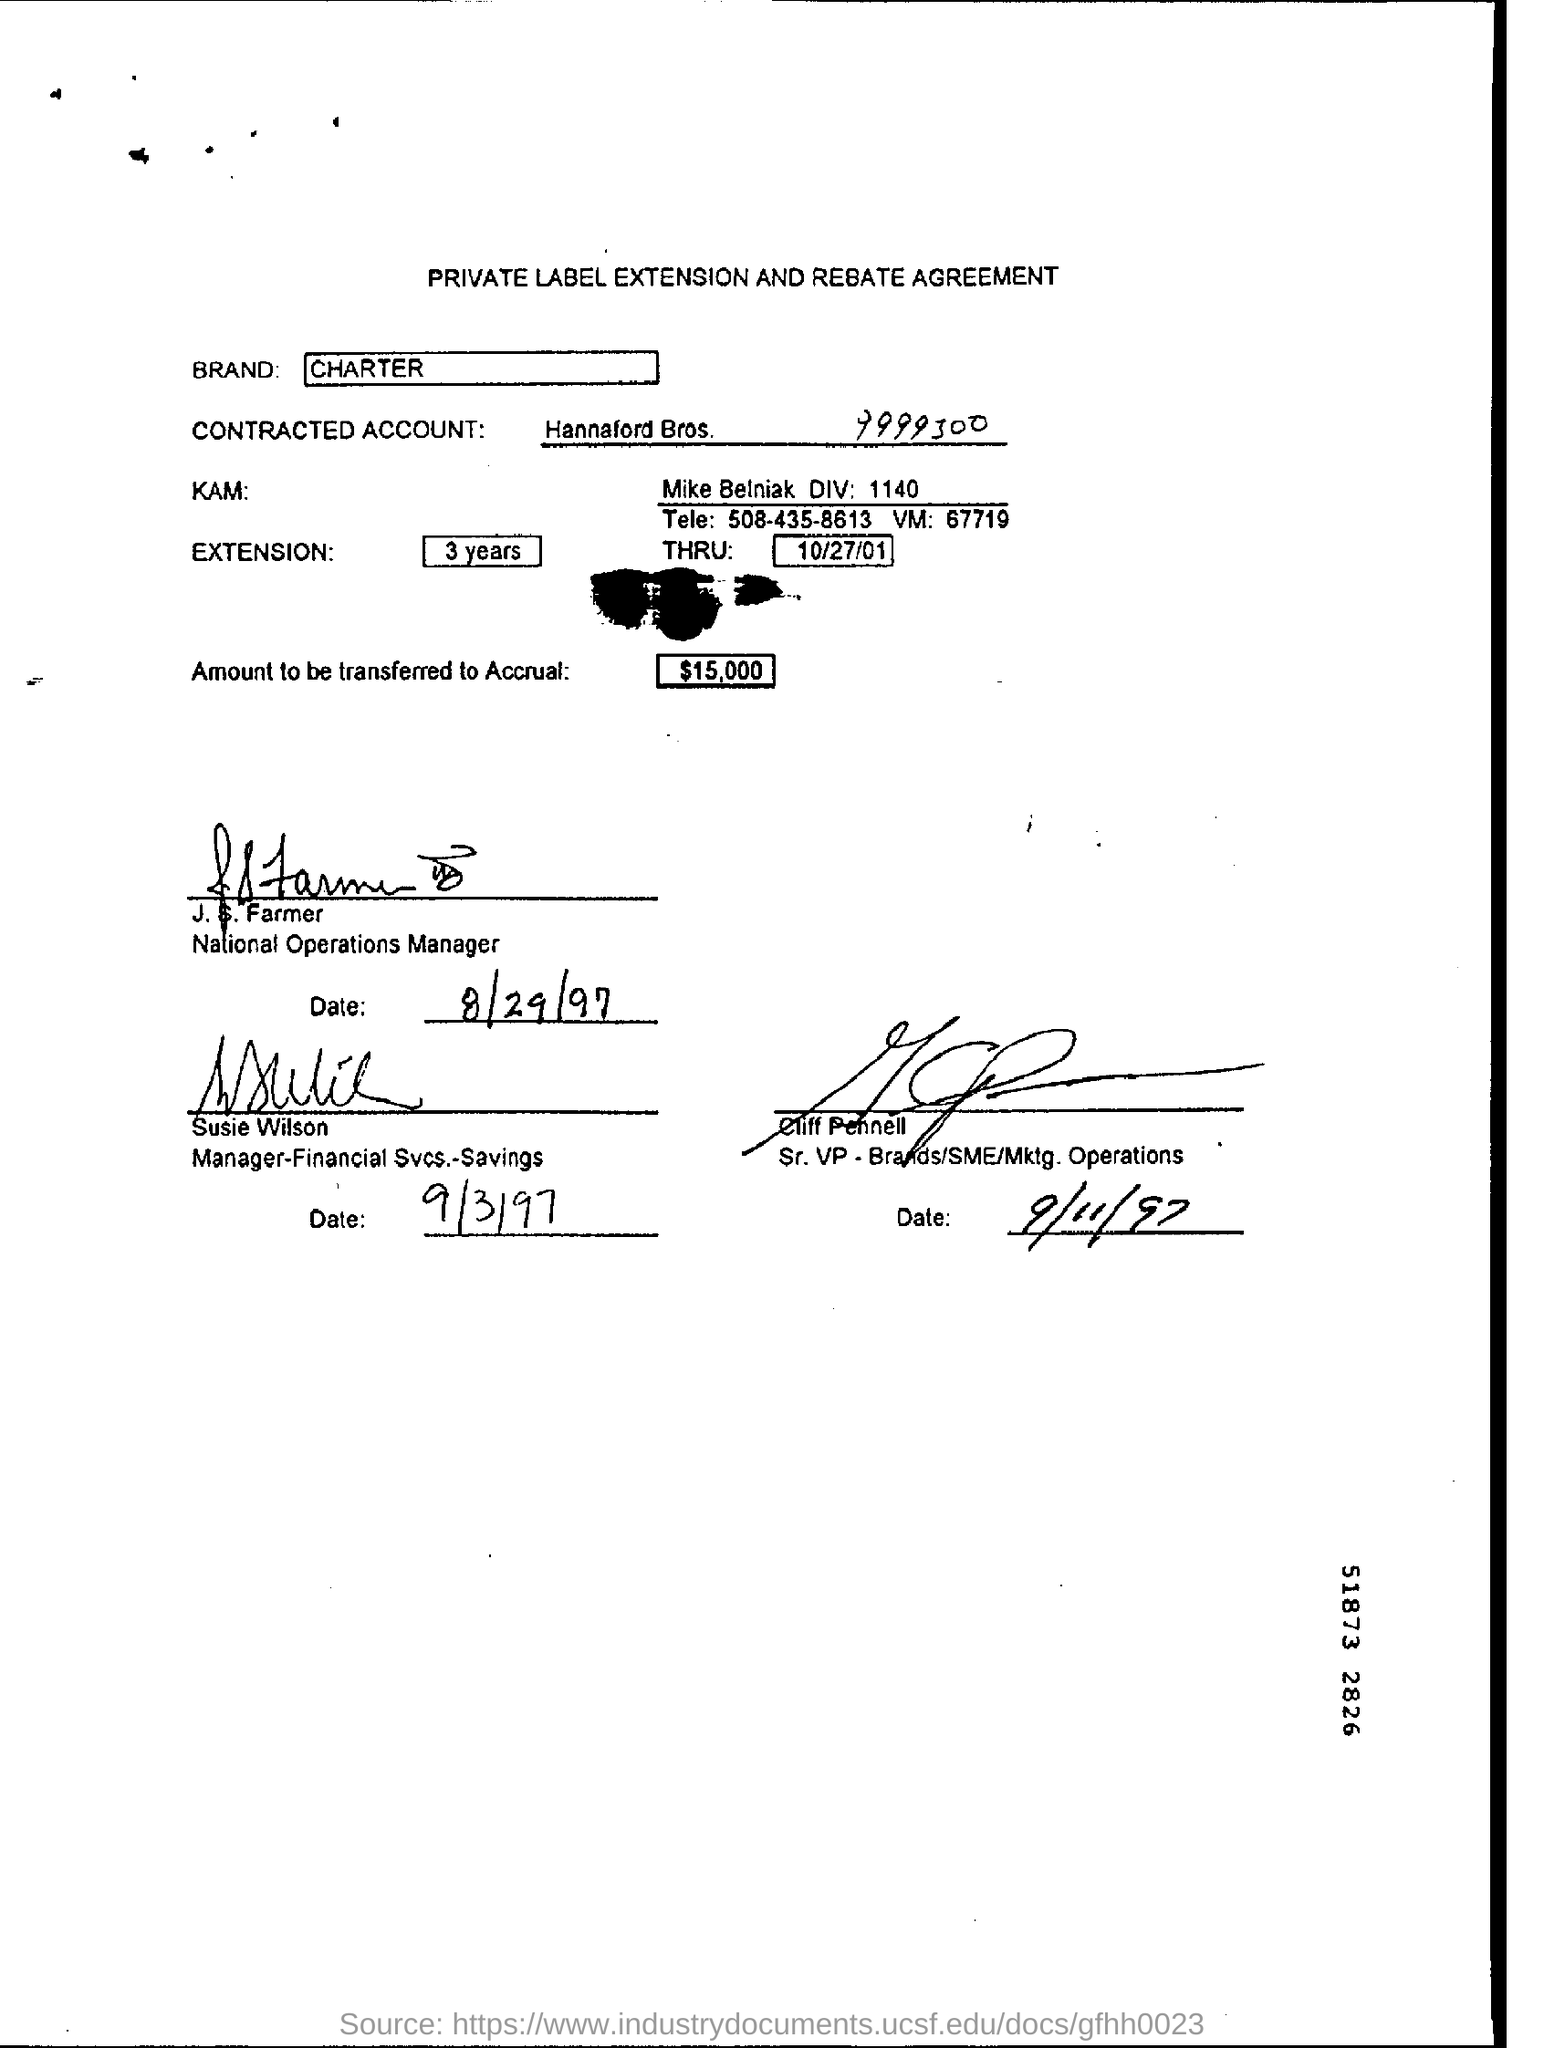Give some essential details in this illustration. The brand name is Charter. What is written in the THRU file on October 27, 2001? The Extension Field contains the written information '3 years'. The contracted account number is 9999300... The letter head contains the text 'PRIVATE LABEL EXTENSION AND REBATE AGREEMENT..' 